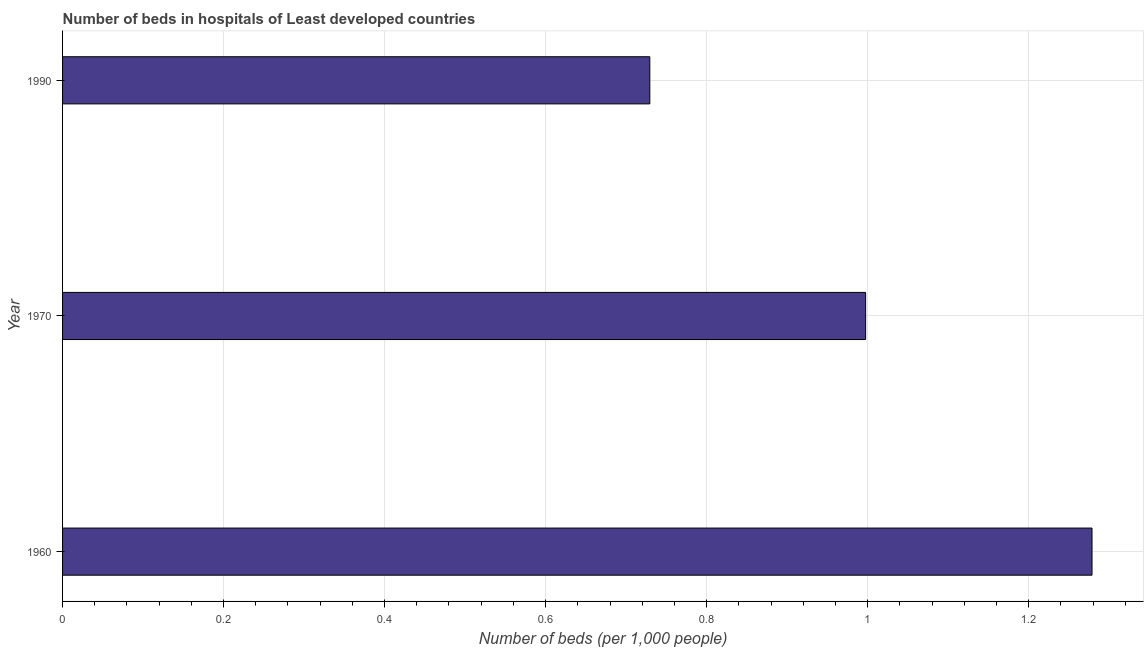Does the graph contain any zero values?
Give a very brief answer. No. Does the graph contain grids?
Provide a short and direct response. Yes. What is the title of the graph?
Ensure brevity in your answer.  Number of beds in hospitals of Least developed countries. What is the label or title of the X-axis?
Keep it short and to the point. Number of beds (per 1,0 people). What is the label or title of the Y-axis?
Your answer should be compact. Year. What is the number of hospital beds in 1970?
Offer a terse response. 1. Across all years, what is the maximum number of hospital beds?
Offer a very short reply. 1.28. Across all years, what is the minimum number of hospital beds?
Give a very brief answer. 0.73. In which year was the number of hospital beds minimum?
Ensure brevity in your answer.  1990. What is the sum of the number of hospital beds?
Offer a terse response. 3.01. What is the difference between the number of hospital beds in 1960 and 1990?
Your answer should be very brief. 0.55. What is the average number of hospital beds per year?
Your response must be concise. 1. What is the median number of hospital beds?
Your response must be concise. 1. Do a majority of the years between 1960 and 1970 (inclusive) have number of hospital beds greater than 1.12 %?
Your answer should be compact. No. What is the ratio of the number of hospital beds in 1960 to that in 1990?
Give a very brief answer. 1.75. Is the number of hospital beds in 1960 less than that in 1990?
Offer a terse response. No. Is the difference between the number of hospital beds in 1960 and 1990 greater than the difference between any two years?
Make the answer very short. Yes. What is the difference between the highest and the second highest number of hospital beds?
Offer a very short reply. 0.28. What is the difference between the highest and the lowest number of hospital beds?
Make the answer very short. 0.55. In how many years, is the number of hospital beds greater than the average number of hospital beds taken over all years?
Offer a very short reply. 1. Are the values on the major ticks of X-axis written in scientific E-notation?
Provide a short and direct response. No. What is the Number of beds (per 1,000 people) in 1960?
Your answer should be very brief. 1.28. What is the Number of beds (per 1,000 people) in 1970?
Your answer should be very brief. 1. What is the Number of beds (per 1,000 people) in 1990?
Make the answer very short. 0.73. What is the difference between the Number of beds (per 1,000 people) in 1960 and 1970?
Make the answer very short. 0.28. What is the difference between the Number of beds (per 1,000 people) in 1960 and 1990?
Give a very brief answer. 0.55. What is the difference between the Number of beds (per 1,000 people) in 1970 and 1990?
Your answer should be compact. 0.27. What is the ratio of the Number of beds (per 1,000 people) in 1960 to that in 1970?
Provide a succinct answer. 1.28. What is the ratio of the Number of beds (per 1,000 people) in 1960 to that in 1990?
Provide a succinct answer. 1.75. What is the ratio of the Number of beds (per 1,000 people) in 1970 to that in 1990?
Your response must be concise. 1.37. 